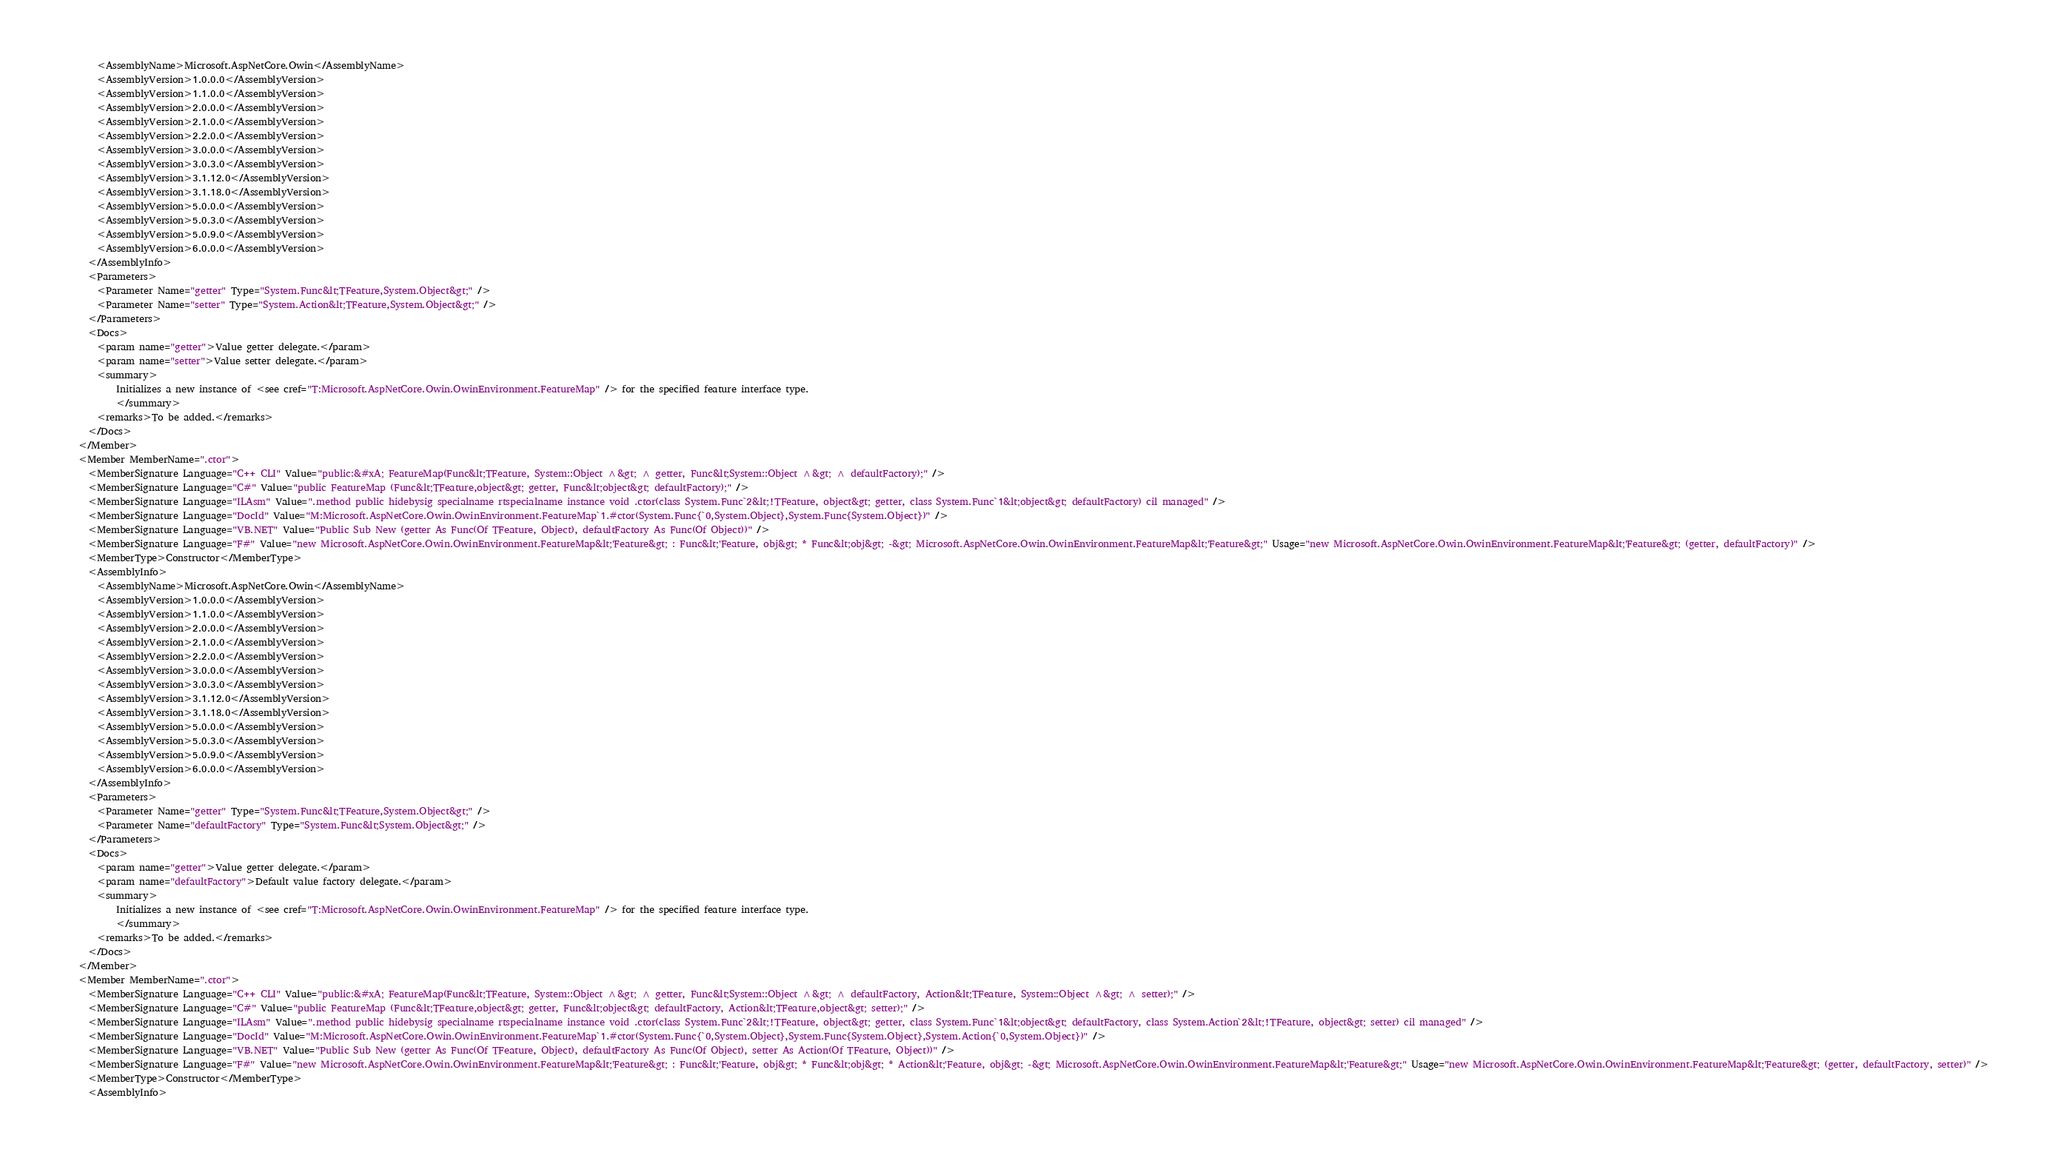Convert code to text. <code><loc_0><loc_0><loc_500><loc_500><_XML_>        <AssemblyName>Microsoft.AspNetCore.Owin</AssemblyName>
        <AssemblyVersion>1.0.0.0</AssemblyVersion>
        <AssemblyVersion>1.1.0.0</AssemblyVersion>
        <AssemblyVersion>2.0.0.0</AssemblyVersion>
        <AssemblyVersion>2.1.0.0</AssemblyVersion>
        <AssemblyVersion>2.2.0.0</AssemblyVersion>
        <AssemblyVersion>3.0.0.0</AssemblyVersion>
        <AssemblyVersion>3.0.3.0</AssemblyVersion>
        <AssemblyVersion>3.1.12.0</AssemblyVersion>
        <AssemblyVersion>3.1.18.0</AssemblyVersion>
        <AssemblyVersion>5.0.0.0</AssemblyVersion>
        <AssemblyVersion>5.0.3.0</AssemblyVersion>
        <AssemblyVersion>5.0.9.0</AssemblyVersion>
        <AssemblyVersion>6.0.0.0</AssemblyVersion>
      </AssemblyInfo>
      <Parameters>
        <Parameter Name="getter" Type="System.Func&lt;TFeature,System.Object&gt;" />
        <Parameter Name="setter" Type="System.Action&lt;TFeature,System.Object&gt;" />
      </Parameters>
      <Docs>
        <param name="getter">Value getter delegate.</param>
        <param name="setter">Value setter delegate.</param>
        <summary>
            Initializes a new instance of <see cref="T:Microsoft.AspNetCore.Owin.OwinEnvironment.FeatureMap" /> for the specified feature interface type.
            </summary>
        <remarks>To be added.</remarks>
      </Docs>
    </Member>
    <Member MemberName=".ctor">
      <MemberSignature Language="C++ CLI" Value="public:&#xA; FeatureMap(Func&lt;TFeature, System::Object ^&gt; ^ getter, Func&lt;System::Object ^&gt; ^ defaultFactory);" />
      <MemberSignature Language="C#" Value="public FeatureMap (Func&lt;TFeature,object&gt; getter, Func&lt;object&gt; defaultFactory);" />
      <MemberSignature Language="ILAsm" Value=".method public hidebysig specialname rtspecialname instance void .ctor(class System.Func`2&lt;!TFeature, object&gt; getter, class System.Func`1&lt;object&gt; defaultFactory) cil managed" />
      <MemberSignature Language="DocId" Value="M:Microsoft.AspNetCore.Owin.OwinEnvironment.FeatureMap`1.#ctor(System.Func{`0,System.Object},System.Func{System.Object})" />
      <MemberSignature Language="VB.NET" Value="Public Sub New (getter As Func(Of TFeature, Object), defaultFactory As Func(Of Object))" />
      <MemberSignature Language="F#" Value="new Microsoft.AspNetCore.Owin.OwinEnvironment.FeatureMap&lt;'Feature&gt; : Func&lt;'Feature, obj&gt; * Func&lt;obj&gt; -&gt; Microsoft.AspNetCore.Owin.OwinEnvironment.FeatureMap&lt;'Feature&gt;" Usage="new Microsoft.AspNetCore.Owin.OwinEnvironment.FeatureMap&lt;'Feature&gt; (getter, defaultFactory)" />
      <MemberType>Constructor</MemberType>
      <AssemblyInfo>
        <AssemblyName>Microsoft.AspNetCore.Owin</AssemblyName>
        <AssemblyVersion>1.0.0.0</AssemblyVersion>
        <AssemblyVersion>1.1.0.0</AssemblyVersion>
        <AssemblyVersion>2.0.0.0</AssemblyVersion>
        <AssemblyVersion>2.1.0.0</AssemblyVersion>
        <AssemblyVersion>2.2.0.0</AssemblyVersion>
        <AssemblyVersion>3.0.0.0</AssemblyVersion>
        <AssemblyVersion>3.0.3.0</AssemblyVersion>
        <AssemblyVersion>3.1.12.0</AssemblyVersion>
        <AssemblyVersion>3.1.18.0</AssemblyVersion>
        <AssemblyVersion>5.0.0.0</AssemblyVersion>
        <AssemblyVersion>5.0.3.0</AssemblyVersion>
        <AssemblyVersion>5.0.9.0</AssemblyVersion>
        <AssemblyVersion>6.0.0.0</AssemblyVersion>
      </AssemblyInfo>
      <Parameters>
        <Parameter Name="getter" Type="System.Func&lt;TFeature,System.Object&gt;" />
        <Parameter Name="defaultFactory" Type="System.Func&lt;System.Object&gt;" />
      </Parameters>
      <Docs>
        <param name="getter">Value getter delegate.</param>
        <param name="defaultFactory">Default value factory delegate.</param>
        <summary>
            Initializes a new instance of <see cref="T:Microsoft.AspNetCore.Owin.OwinEnvironment.FeatureMap" /> for the specified feature interface type.
            </summary>
        <remarks>To be added.</remarks>
      </Docs>
    </Member>
    <Member MemberName=".ctor">
      <MemberSignature Language="C++ CLI" Value="public:&#xA; FeatureMap(Func&lt;TFeature, System::Object ^&gt; ^ getter, Func&lt;System::Object ^&gt; ^ defaultFactory, Action&lt;TFeature, System::Object ^&gt; ^ setter);" />
      <MemberSignature Language="C#" Value="public FeatureMap (Func&lt;TFeature,object&gt; getter, Func&lt;object&gt; defaultFactory, Action&lt;TFeature,object&gt; setter);" />
      <MemberSignature Language="ILAsm" Value=".method public hidebysig specialname rtspecialname instance void .ctor(class System.Func`2&lt;!TFeature, object&gt; getter, class System.Func`1&lt;object&gt; defaultFactory, class System.Action`2&lt;!TFeature, object&gt; setter) cil managed" />
      <MemberSignature Language="DocId" Value="M:Microsoft.AspNetCore.Owin.OwinEnvironment.FeatureMap`1.#ctor(System.Func{`0,System.Object},System.Func{System.Object},System.Action{`0,System.Object})" />
      <MemberSignature Language="VB.NET" Value="Public Sub New (getter As Func(Of TFeature, Object), defaultFactory As Func(Of Object), setter As Action(Of TFeature, Object))" />
      <MemberSignature Language="F#" Value="new Microsoft.AspNetCore.Owin.OwinEnvironment.FeatureMap&lt;'Feature&gt; : Func&lt;'Feature, obj&gt; * Func&lt;obj&gt; * Action&lt;'Feature, obj&gt; -&gt; Microsoft.AspNetCore.Owin.OwinEnvironment.FeatureMap&lt;'Feature&gt;" Usage="new Microsoft.AspNetCore.Owin.OwinEnvironment.FeatureMap&lt;'Feature&gt; (getter, defaultFactory, setter)" />
      <MemberType>Constructor</MemberType>
      <AssemblyInfo></code> 